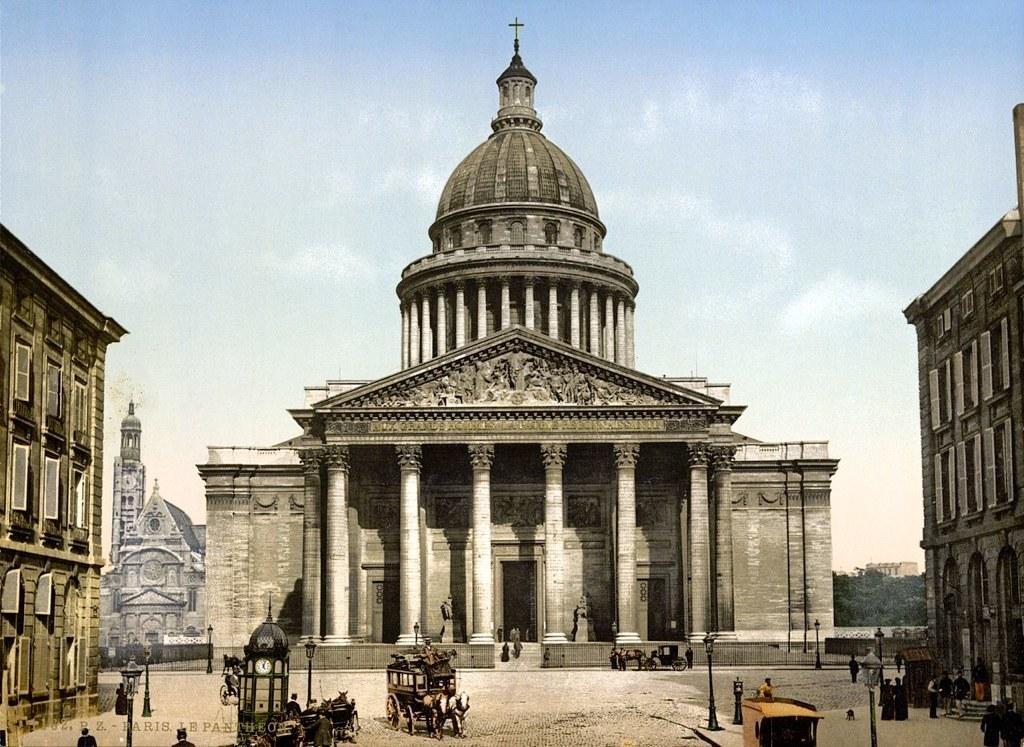Could you give a brief overview of what you see in this image? In this image I can see the horse cart and I can see the horses in white color. In front I can see the clock and few persons standing. Background I can see few buildings in gray and brown color and I can see the trees in green color and the sky is in blue and white color. 